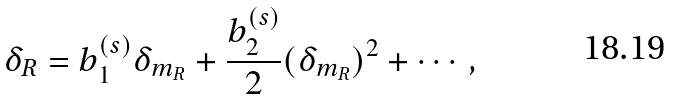Convert formula to latex. <formula><loc_0><loc_0><loc_500><loc_500>\delta _ { R } = b _ { 1 } ^ { ( s ) } \delta _ { m _ { R } } + \frac { b _ { 2 } ^ { ( s ) } } { 2 } ( \delta _ { m _ { R } } ) ^ { 2 } + \cdots ,</formula> 